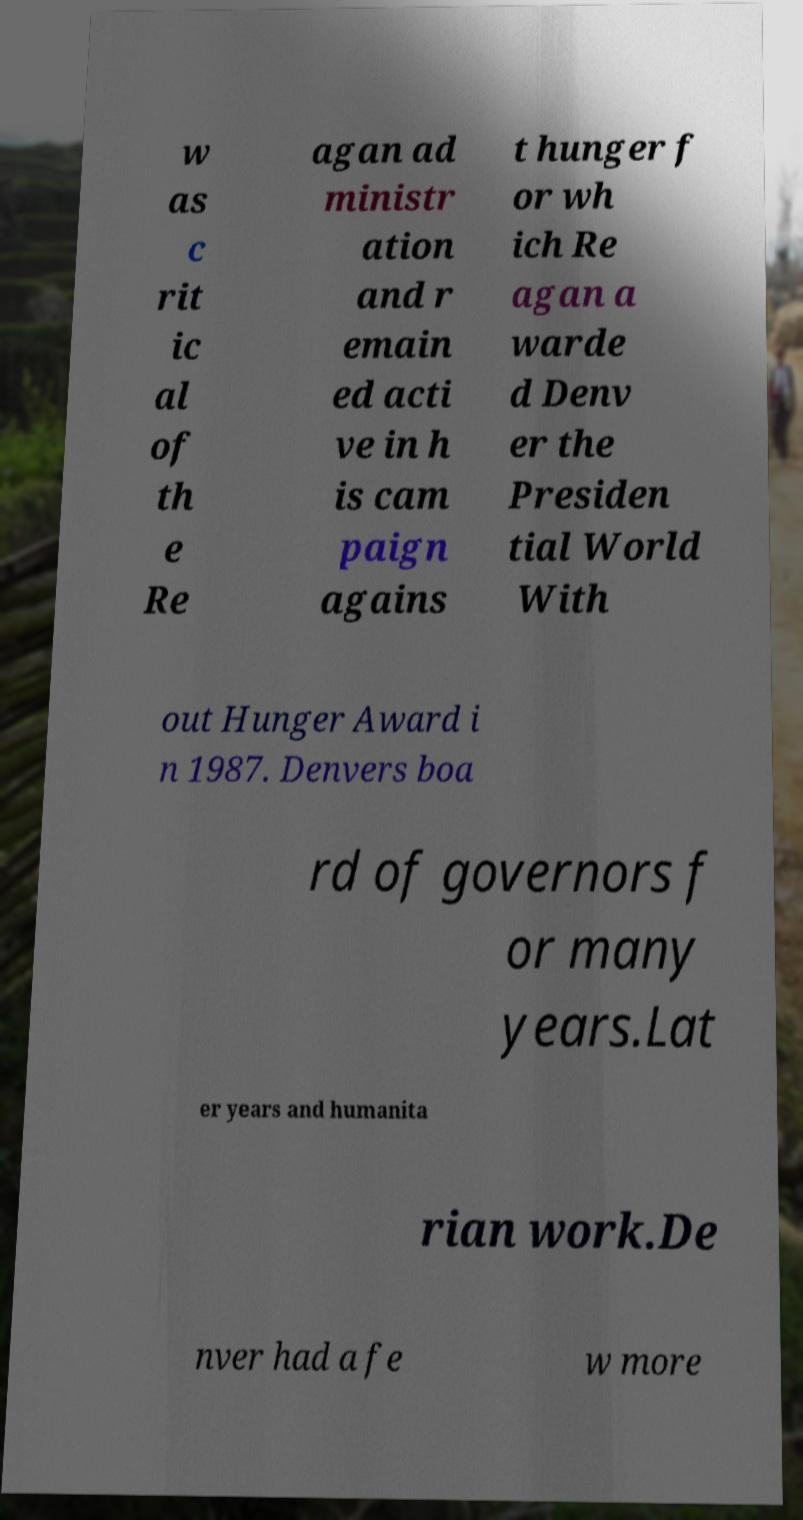What messages or text are displayed in this image? I need them in a readable, typed format. w as c rit ic al of th e Re agan ad ministr ation and r emain ed acti ve in h is cam paign agains t hunger f or wh ich Re agan a warde d Denv er the Presiden tial World With out Hunger Award i n 1987. Denvers boa rd of governors f or many years.Lat er years and humanita rian work.De nver had a fe w more 